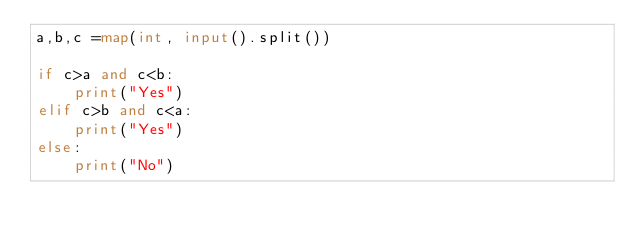<code> <loc_0><loc_0><loc_500><loc_500><_Python_>a,b,c =map(int, input().split())

if c>a and c<b:
    print("Yes")
elif c>b and c<a:
    print("Yes")
else:
    print("No")</code> 